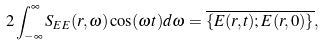<formula> <loc_0><loc_0><loc_500><loc_500>2 \int _ { - \infty } ^ { \infty } S _ { E E } ( { r } , \omega ) \cos ( \omega t ) d \omega = \overline { \{ { E } ( { r } , t ) ; { E } ( { r } , 0 ) \} } ,</formula> 